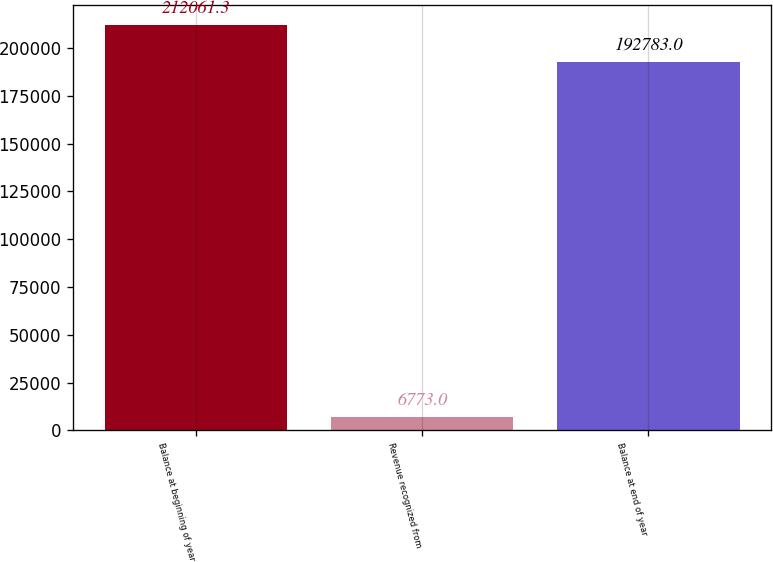Convert chart. <chart><loc_0><loc_0><loc_500><loc_500><bar_chart><fcel>Balance at beginning of year<fcel>Revenue recognized from<fcel>Balance at end of year<nl><fcel>212061<fcel>6773<fcel>192783<nl></chart> 